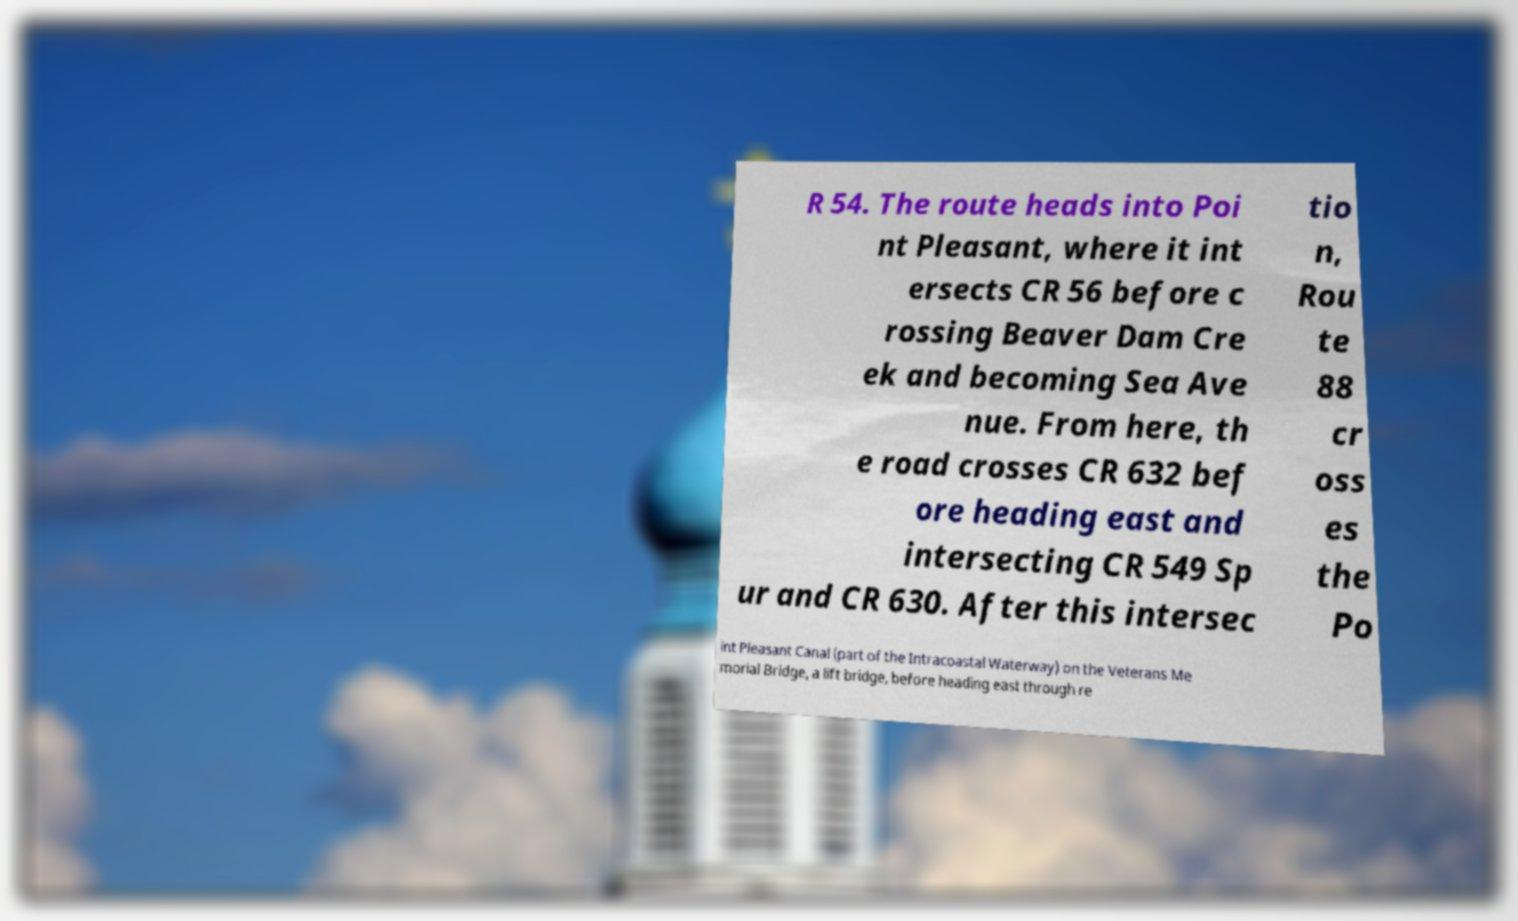There's text embedded in this image that I need extracted. Can you transcribe it verbatim? R 54. The route heads into Poi nt Pleasant, where it int ersects CR 56 before c rossing Beaver Dam Cre ek and becoming Sea Ave nue. From here, th e road crosses CR 632 bef ore heading east and intersecting CR 549 Sp ur and CR 630. After this intersec tio n, Rou te 88 cr oss es the Po int Pleasant Canal (part of the Intracoastal Waterway) on the Veterans Me morial Bridge, a lift bridge, before heading east through re 